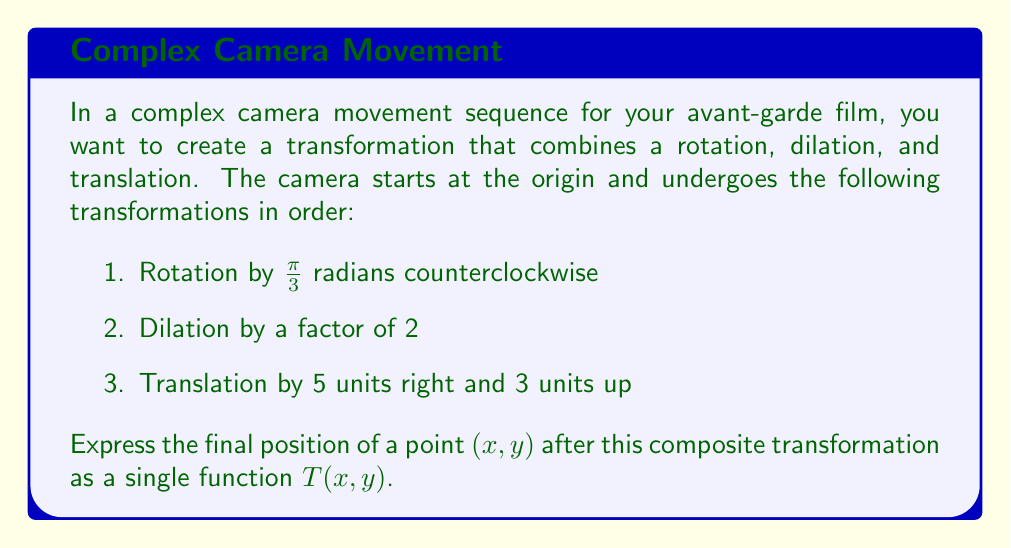Give your solution to this math problem. To solve this problem, we need to apply each transformation in order and combine them into a single composite function. Let's break it down step by step:

1. Rotation by $\frac{\pi}{3}$ radians counterclockwise:
   The rotation matrix for this transformation is:
   $$R = \begin{bmatrix} \cos(\frac{\pi}{3}) & -\sin(\frac{\pi}{3}) \\ \sin(\frac{\pi}{3}) & \cos(\frac{\pi}{3}) \end{bmatrix} = \begin{bmatrix} \frac{1}{2} & -\frac{\sqrt{3}}{2} \\ \frac{\sqrt{3}}{2} & \frac{1}{2} \end{bmatrix}$$

2. Dilation by a factor of 2:
   The dilation matrix is:
   $$D = \begin{bmatrix} 2 & 0 \\ 0 & 2 \end{bmatrix}$$

3. Translation by 5 units right and 3 units up:
   This can be represented as adding a vector $\begin{bmatrix} 5 \\ 3 \end{bmatrix}$

Now, let's combine these transformations:
$$T(x, y) = D \cdot R \cdot \begin{bmatrix} x \\ y \end{bmatrix} + \begin{bmatrix} 5 \\ 3 \end{bmatrix}$$

Multiplying the matrices:
$$T(x, y) = \begin{bmatrix} 2 & 0 \\ 0 & 2 \end{bmatrix} \cdot \begin{bmatrix} \frac{1}{2} & -\frac{\sqrt{3}}{2} \\ \frac{\sqrt{3}}{2} & \frac{1}{2} \end{bmatrix} \cdot \begin{bmatrix} x \\ y \end{bmatrix} + \begin{bmatrix} 5 \\ 3 \end{bmatrix}$$

$$T(x, y) = \begin{bmatrix} 1 & -\sqrt{3} \\ \sqrt{3} & 1 \end{bmatrix} \cdot \begin{bmatrix} x \\ y \end{bmatrix} + \begin{bmatrix} 5 \\ 3 \end{bmatrix}$$

Multiplying out the matrix:
$$T(x, y) = \begin{bmatrix} x - \sqrt{3}y + 5 \\ \sqrt{3}x + y + 3 \end{bmatrix}$$
Answer: The final composite transformation $T(x, y)$ is:

$$T(x, y) = \begin{bmatrix} x - \sqrt{3}y + 5 \\ \sqrt{3}x + y + 3 \end{bmatrix}$$ 